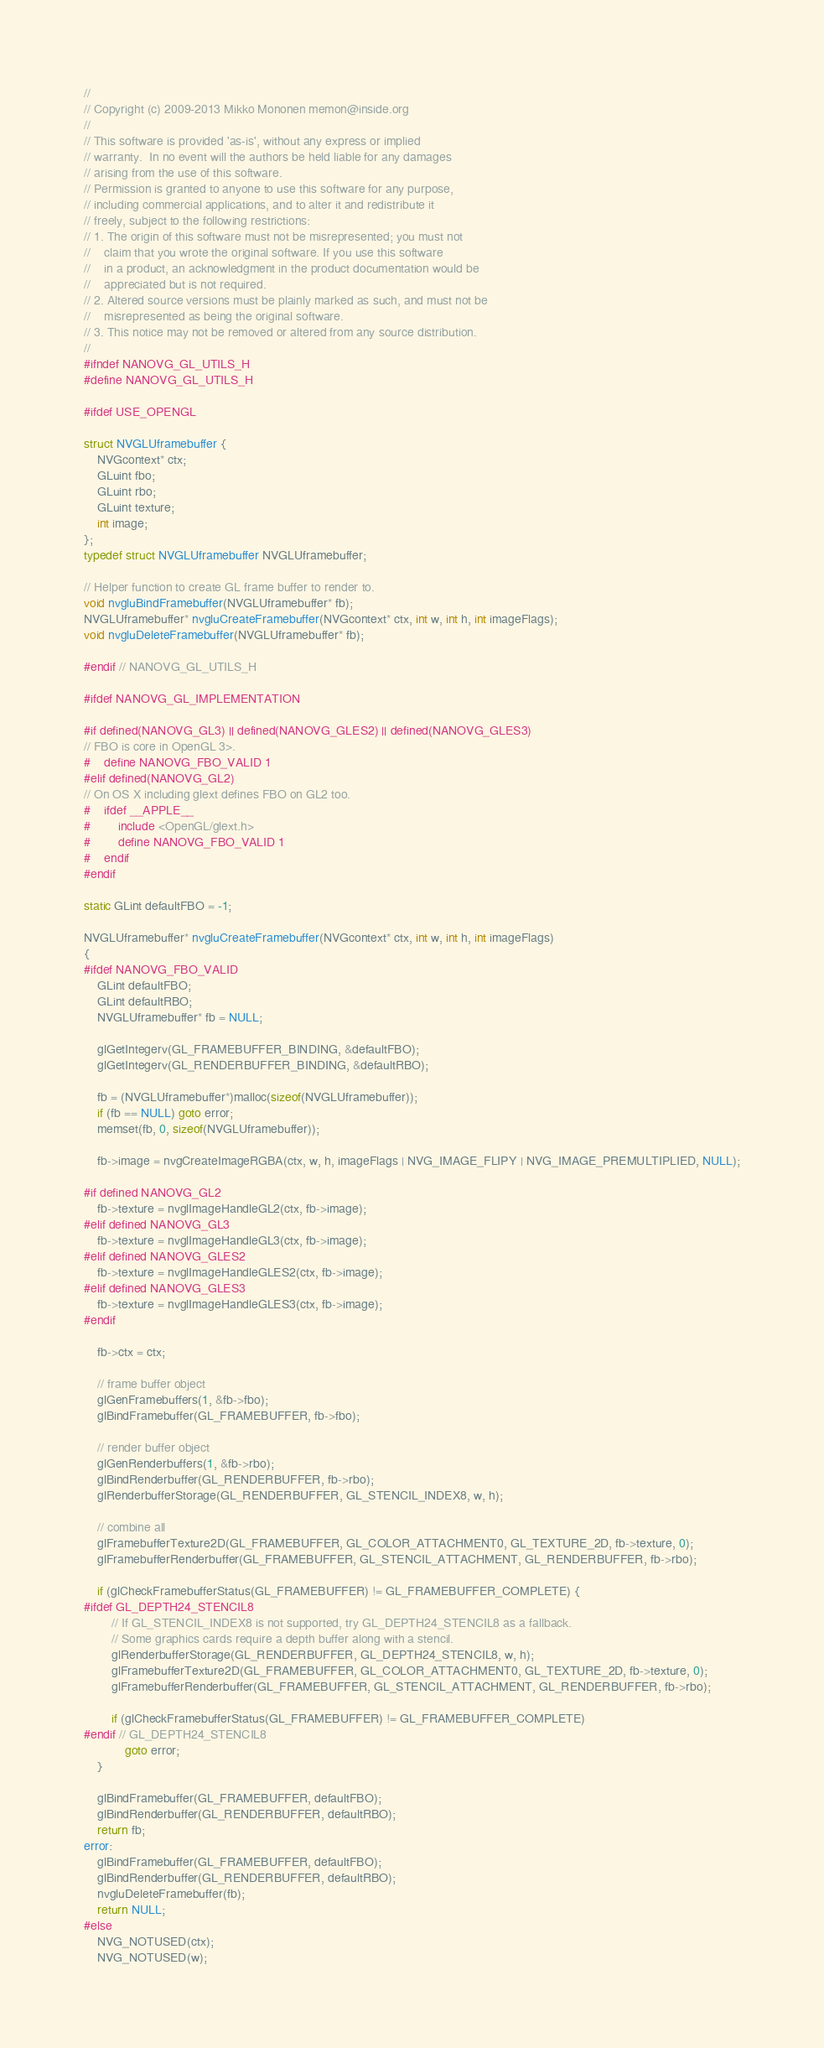<code> <loc_0><loc_0><loc_500><loc_500><_C_>//
// Copyright (c) 2009-2013 Mikko Mononen memon@inside.org
//
// This software is provided 'as-is', without any express or implied
// warranty.  In no event will the authors be held liable for any damages
// arising from the use of this software.
// Permission is granted to anyone to use this software for any purpose,
// including commercial applications, and to alter it and redistribute it
// freely, subject to the following restrictions:
// 1. The origin of this software must not be misrepresented; you must not
//    claim that you wrote the original software. If you use this software
//    in a product, an acknowledgment in the product documentation would be
//    appreciated but is not required.
// 2. Altered source versions must be plainly marked as such, and must not be
//    misrepresented as being the original software.
// 3. This notice may not be removed or altered from any source distribution.
//
#ifndef NANOVG_GL_UTILS_H
#define NANOVG_GL_UTILS_H

#ifdef USE_OPENGL

struct NVGLUframebuffer {
    NVGcontext* ctx;
    GLuint fbo;
    GLuint rbo;
    GLuint texture;
    int image;
};
typedef struct NVGLUframebuffer NVGLUframebuffer;

// Helper function to create GL frame buffer to render to.
void nvgluBindFramebuffer(NVGLUframebuffer* fb);
NVGLUframebuffer* nvgluCreateFramebuffer(NVGcontext* ctx, int w, int h, int imageFlags);
void nvgluDeleteFramebuffer(NVGLUframebuffer* fb);

#endif // NANOVG_GL_UTILS_H

#ifdef NANOVG_GL_IMPLEMENTATION

#if defined(NANOVG_GL3) || defined(NANOVG_GLES2) || defined(NANOVG_GLES3)
// FBO is core in OpenGL 3>.
#	define NANOVG_FBO_VALID 1
#elif defined(NANOVG_GL2)
// On OS X including glext defines FBO on GL2 too.
#	ifdef __APPLE__
#		include <OpenGL/glext.h>
#		define NANOVG_FBO_VALID 1
#	endif
#endif

static GLint defaultFBO = -1;

NVGLUframebuffer* nvgluCreateFramebuffer(NVGcontext* ctx, int w, int h, int imageFlags)
{
#ifdef NANOVG_FBO_VALID
    GLint defaultFBO;
    GLint defaultRBO;
    NVGLUframebuffer* fb = NULL;

    glGetIntegerv(GL_FRAMEBUFFER_BINDING, &defaultFBO);
    glGetIntegerv(GL_RENDERBUFFER_BINDING, &defaultRBO);

    fb = (NVGLUframebuffer*)malloc(sizeof(NVGLUframebuffer));
    if (fb == NULL) goto error;
    memset(fb, 0, sizeof(NVGLUframebuffer));

    fb->image = nvgCreateImageRGBA(ctx, w, h, imageFlags | NVG_IMAGE_FLIPY | NVG_IMAGE_PREMULTIPLIED, NULL);

#if defined NANOVG_GL2
    fb->texture = nvglImageHandleGL2(ctx, fb->image);
#elif defined NANOVG_GL3
    fb->texture = nvglImageHandleGL3(ctx, fb->image);
#elif defined NANOVG_GLES2
    fb->texture = nvglImageHandleGLES2(ctx, fb->image);
#elif defined NANOVG_GLES3
    fb->texture = nvglImageHandleGLES3(ctx, fb->image);
#endif

    fb->ctx = ctx;

    // frame buffer object
    glGenFramebuffers(1, &fb->fbo);
    glBindFramebuffer(GL_FRAMEBUFFER, fb->fbo);

    // render buffer object
    glGenRenderbuffers(1, &fb->rbo);
    glBindRenderbuffer(GL_RENDERBUFFER, fb->rbo);
    glRenderbufferStorage(GL_RENDERBUFFER, GL_STENCIL_INDEX8, w, h);

    // combine all
    glFramebufferTexture2D(GL_FRAMEBUFFER, GL_COLOR_ATTACHMENT0, GL_TEXTURE_2D, fb->texture, 0);
    glFramebufferRenderbuffer(GL_FRAMEBUFFER, GL_STENCIL_ATTACHMENT, GL_RENDERBUFFER, fb->rbo);

    if (glCheckFramebufferStatus(GL_FRAMEBUFFER) != GL_FRAMEBUFFER_COMPLETE) {
#ifdef GL_DEPTH24_STENCIL8
        // If GL_STENCIL_INDEX8 is not supported, try GL_DEPTH24_STENCIL8 as a fallback.
        // Some graphics cards require a depth buffer along with a stencil.
        glRenderbufferStorage(GL_RENDERBUFFER, GL_DEPTH24_STENCIL8, w, h);
        glFramebufferTexture2D(GL_FRAMEBUFFER, GL_COLOR_ATTACHMENT0, GL_TEXTURE_2D, fb->texture, 0);
        glFramebufferRenderbuffer(GL_FRAMEBUFFER, GL_STENCIL_ATTACHMENT, GL_RENDERBUFFER, fb->rbo);

        if (glCheckFramebufferStatus(GL_FRAMEBUFFER) != GL_FRAMEBUFFER_COMPLETE)
#endif // GL_DEPTH24_STENCIL8
            goto error;
    }

    glBindFramebuffer(GL_FRAMEBUFFER, defaultFBO);
    glBindRenderbuffer(GL_RENDERBUFFER, defaultRBO);
    return fb;
error:
    glBindFramebuffer(GL_FRAMEBUFFER, defaultFBO);
    glBindRenderbuffer(GL_RENDERBUFFER, defaultRBO);
    nvgluDeleteFramebuffer(fb);
    return NULL;
#else
    NVG_NOTUSED(ctx);
    NVG_NOTUSED(w);</code> 